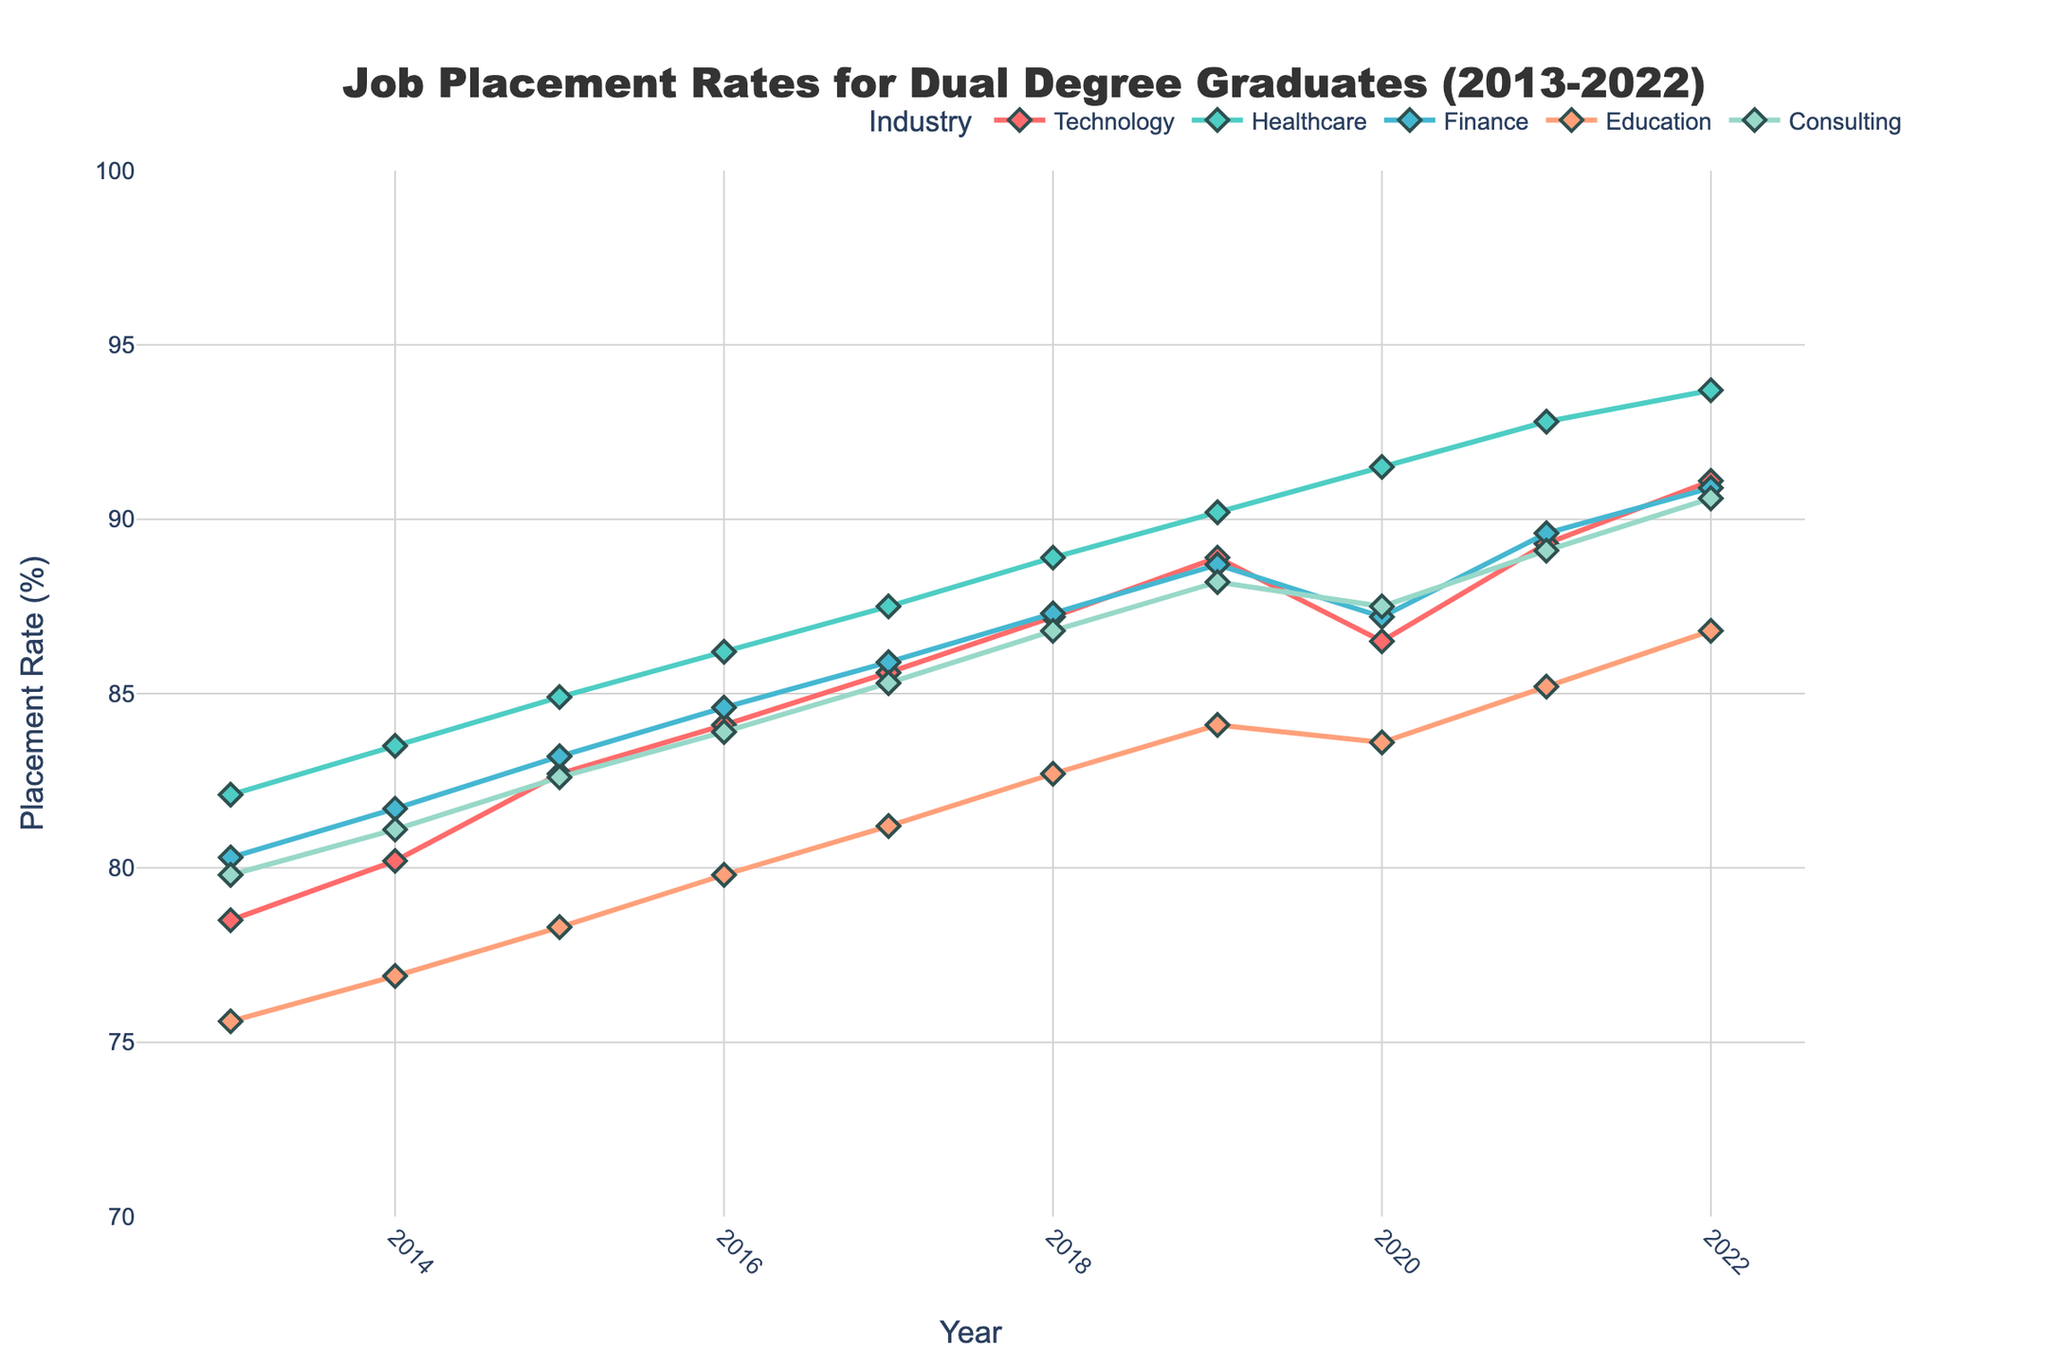Which industry had the highest job placement rate in 2022? To find the answer, look for the industry with the highest value on the y-axis in the year 2022. The lines representing different industries are in different colors, with the placement rates marked at every year. In 2022, Healthcare has the highest value at 93.7%.
Answer: Healthcare What was the job placement rate for the Technology industry in 2020? Locate the line corresponding to Technology and find its y-value in the year 2020. The chart shows Technology's rate as 86.5%.
Answer: 86.5% Between 2017 and 2019, which industry saw the largest increase in job placement rates? Calculate the difference in job placement rates from 2017 to 2019 for each industry by subtracting the 2017 value from the 2019 value. The differences are: Technology (88.9 - 85.6 = 3.3), Healthcare (90.2 - 87.5 = 2.7), Finance (88.7 - 85.9 = 2.8), Education (84.1 - 81.2 = 2.9), Consulting (88.2 - 85.3 = 2.9). Technology has the largest increase of 3.3%.
Answer: Technology Which two years had the smallest difference in job placement rates for Consulting? To find the smallest difference, compare the y-values for Consulting between consecutive years: (2014-2013, 81.1-79.8 = 1.3), (2015-2014, 82.6-81.1 = 1.5), (2016-2015, 83.9-82.6 = 1.3), (2017-2016, 85.3-83.9 = 1.4), (2018-2017, 86.8-85.3 = 1.5), (2019-2018, 88.2-86.8 = 1.4), (2020-2019, 87.5-88.2 = -0.7), (2021-2020, 89.1-87.5 = 1.6), (2022-2021, 90.6-89.1 = 1.5). The smallest difference is between 2019 and 2020 at -0.7.
Answer: 2019 and 2020 What is the average job placement rate across all industries in 2015? Calculate the average of the placement rates for all industries in 2015: (82.7 + 84.9 + 83.2 + 78.3 + 82.6) / 5 = 82.34.
Answer: 82.34 By how much did the job placement rate in the Education industry increase from 2013 to 2022? Find the difference between the placement rates in 2022 and 2013 for Education: 86.8 - 75.6 = 11.2.
Answer: 11.2 Which industry experienced a decrease in job placement rates between 2019 and 2020? Examine the values for each industry between 2019 and 2020. The Technology industry shows a decrease from 88.9% in 2019 to 86.5% in 2020.
Answer: Technology 